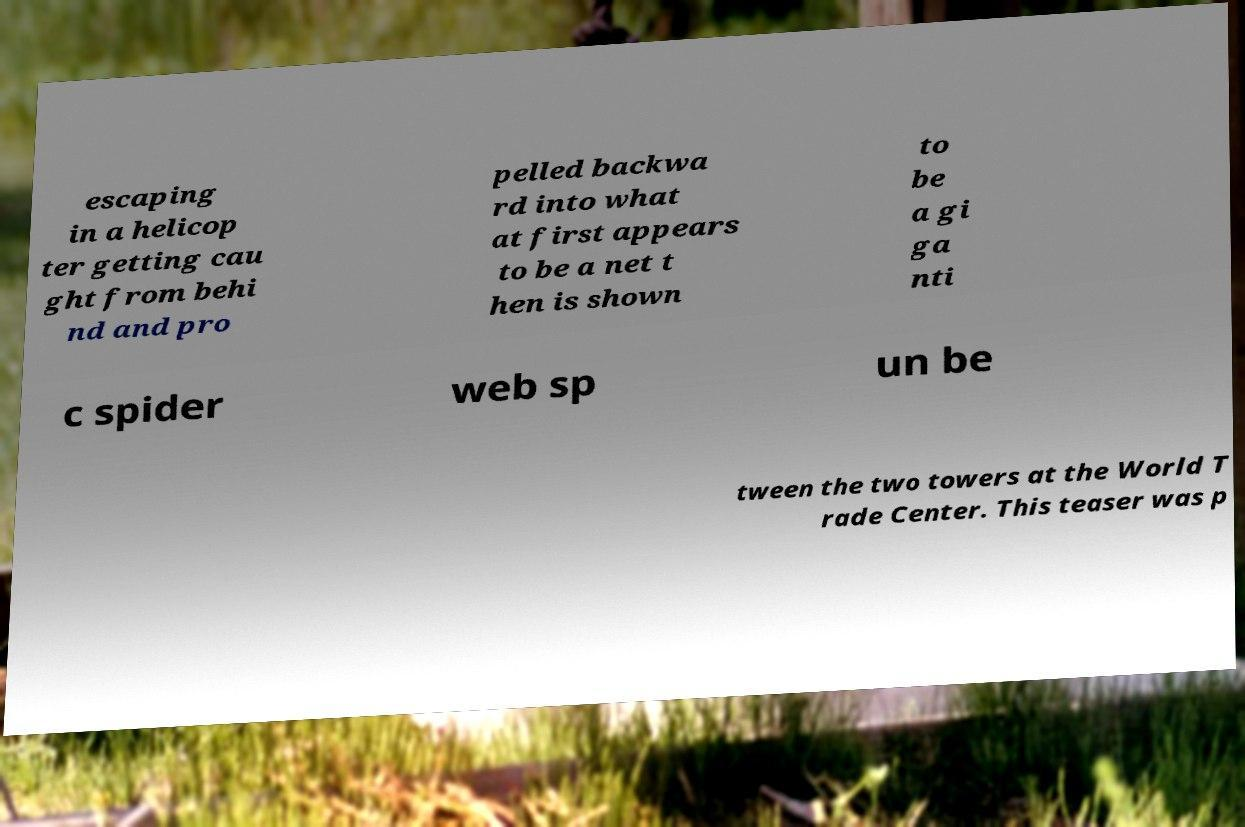What messages or text are displayed in this image? I need them in a readable, typed format. escaping in a helicop ter getting cau ght from behi nd and pro pelled backwa rd into what at first appears to be a net t hen is shown to be a gi ga nti c spider web sp un be tween the two towers at the World T rade Center. This teaser was p 